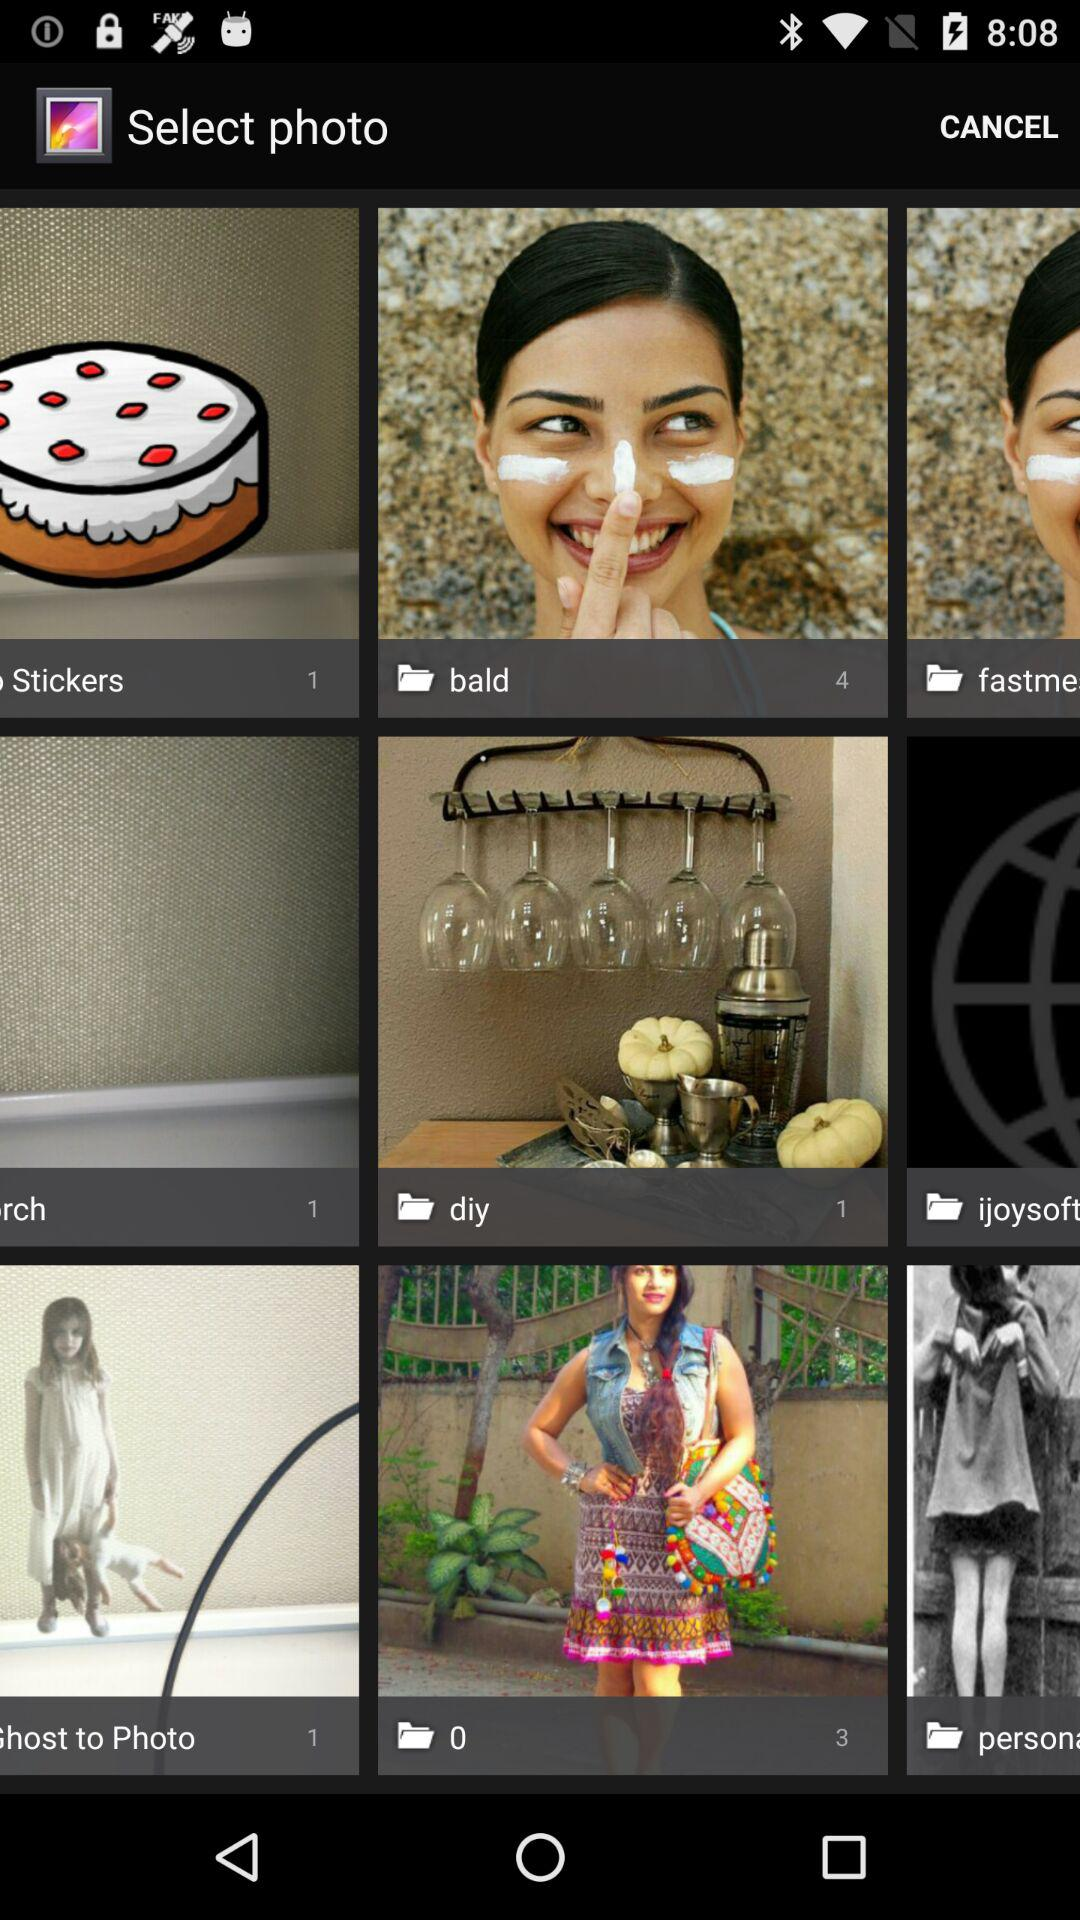How many total photos are there in stickers folder?
When the provided information is insufficient, respond with <no answer>. <no answer> 